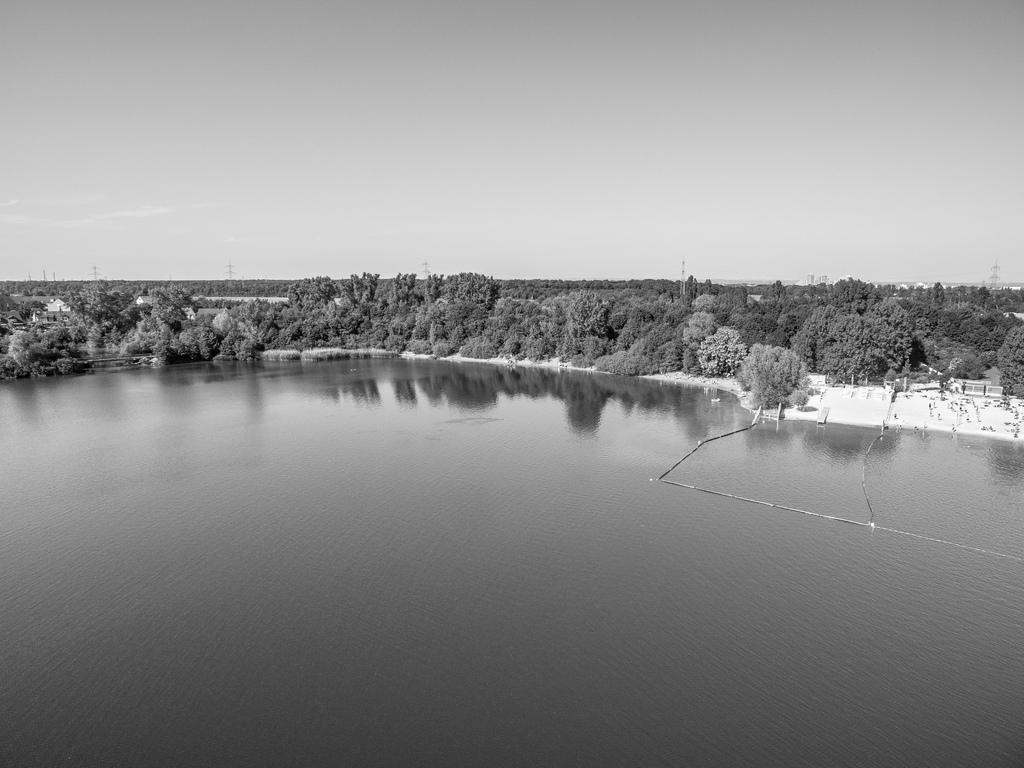What type of vegetation can be seen in the image? There are trees in the image. What else is visible besides the trees? A: There is water visible in the image. Are there any structures present in the image? Yes, there are towers in the image. What can be seen in the background of the image? The sky is visible in the background of the image. What is the color scheme of the image? The image is black and white in color. Can you tell me how many trucks are driving through the stream in the image? There is no stream or truck present in the image. What subject is being taught in the image? There is no teaching or classroom scene depicted in the image. 